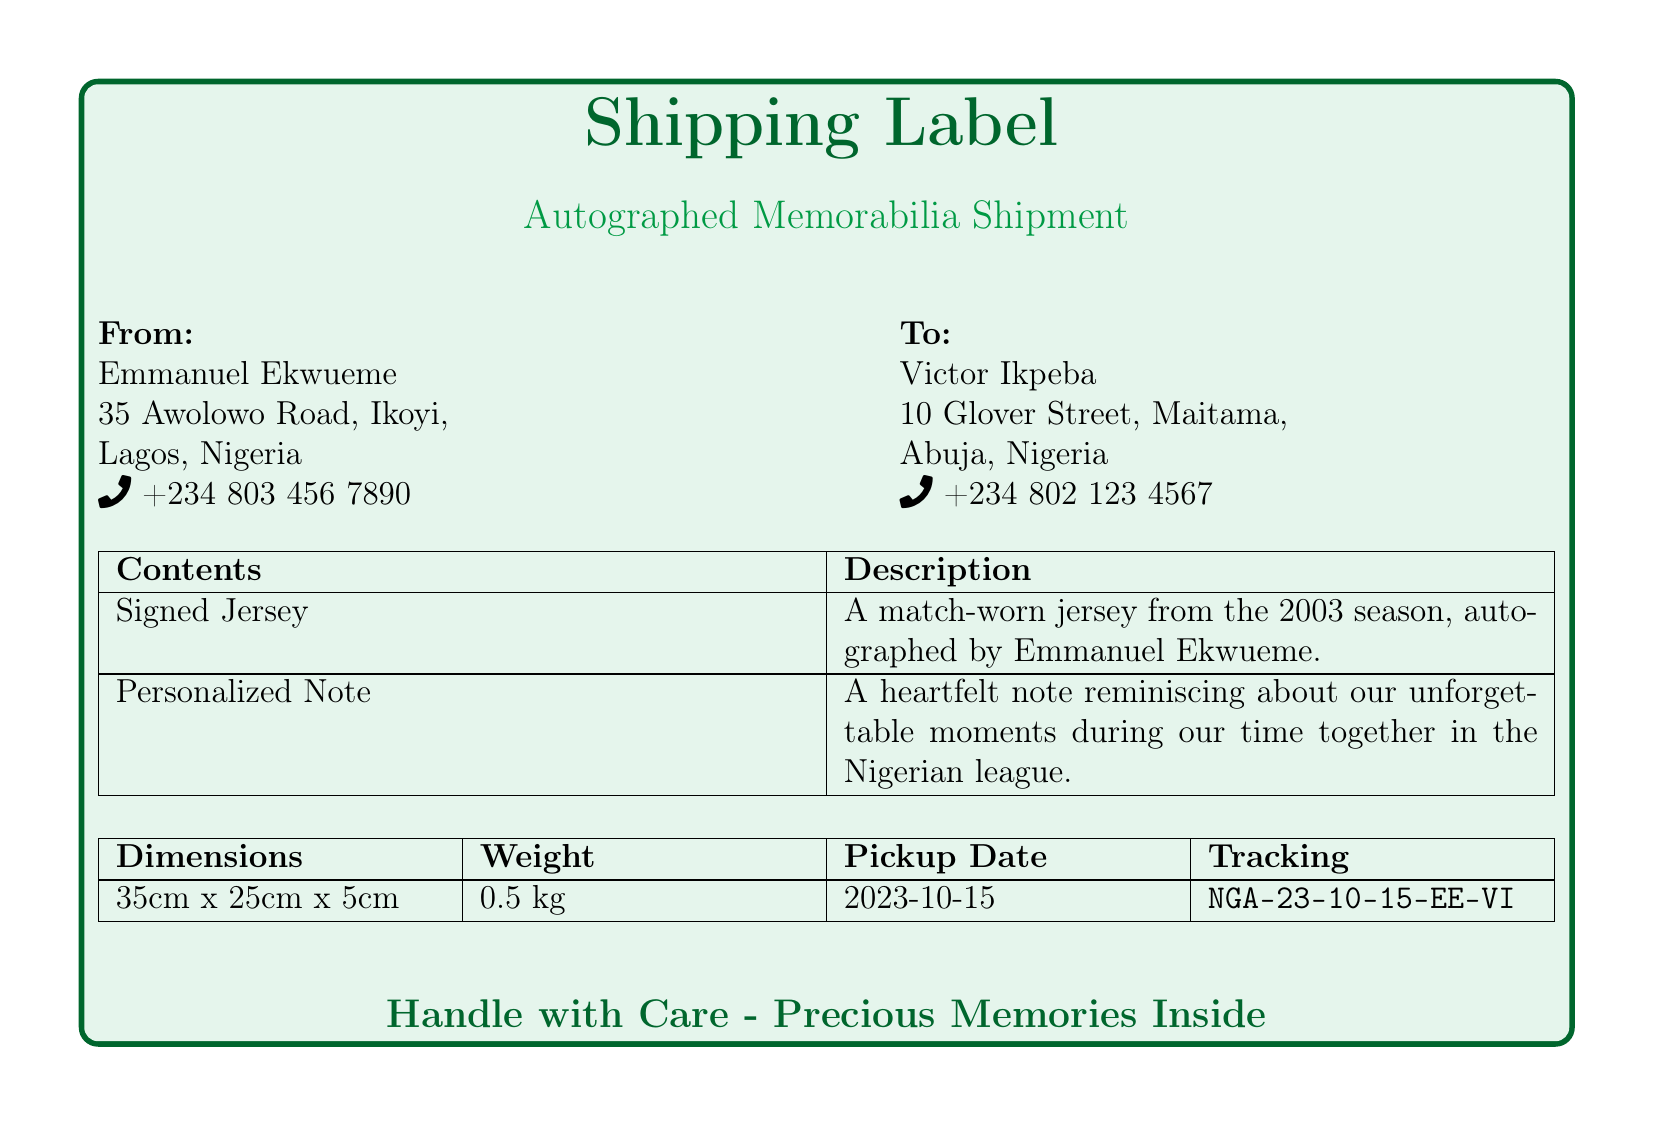What is the name of the sender? The sender's name is specified in the "From" section of the document, which indicates Emmanuel Ekwueme.
Answer: Emmanuel Ekwueme What is the recipient's phone number? The recipient's phone number is listed in the "To" section, which shows +234 802 123 4567.
Answer: +234 802 123 4567 What are the dimensions of the package? The dimensions are provided in the table, indicating the length, width, and height of the package as 35cm x 25cm x 5cm.
Answer: 35cm x 25cm x 5cm What item is being shipped? The contents listed indicate the items being shipped, including a Signed Jersey and a Personalized Note.
Answer: Signed Jersey, Personalized Note What is the pickup date for the shipment? The pickup date is noted in the table, which states it is scheduled for 2023-10-15.
Answer: 2023-10-15 What is the weight of the package? The weight is mentioned in the specifications, recording it as 0.5 kg.
Answer: 0.5 kg What does the personalized note contain? The description under "Personalized Note" highlights it as a heartfelt note reminiscing about their unforgettable moments.
Answer: Unforgettable moments What is the tracking number for the shipment? The tracking number is found in the table, specifically labeled as NGA-23-10-15-EE-VI.
Answer: NGA-23-10-15-EE-VI What color is used for the heading of the shipping label? The document indicates the color used for the heading, which is Nigerian green dark.
Answer: Nigerian green dark 